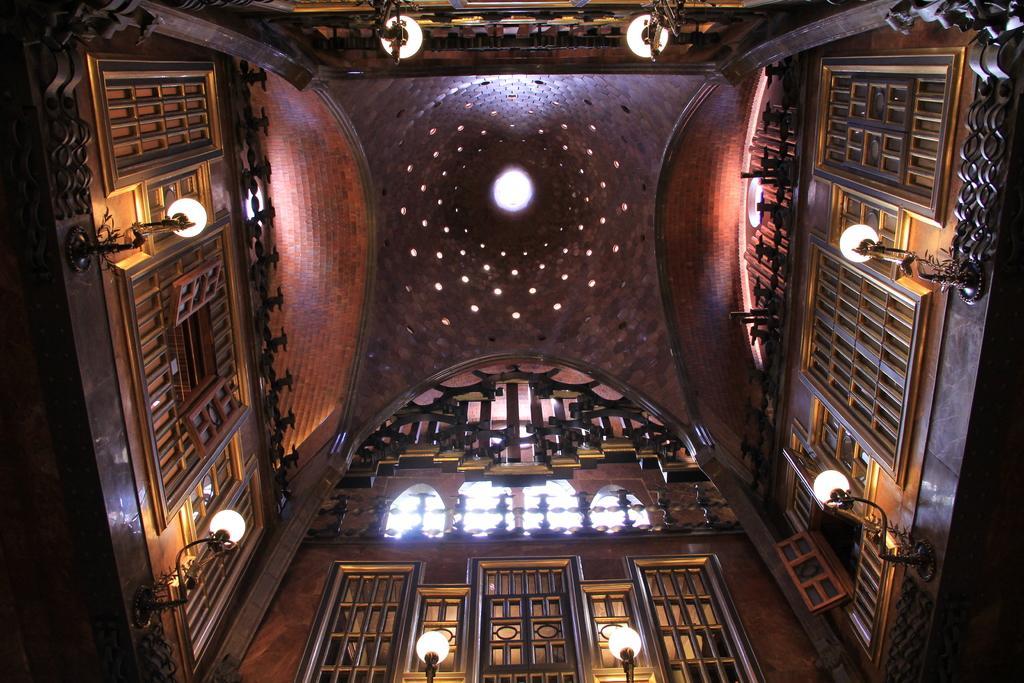Can you describe this image briefly? This picture seems to be clicked inside the hall. In the foreground we can see the windows and the wall mounted lamps. In the background we can see the roof, lights and some other objects. 